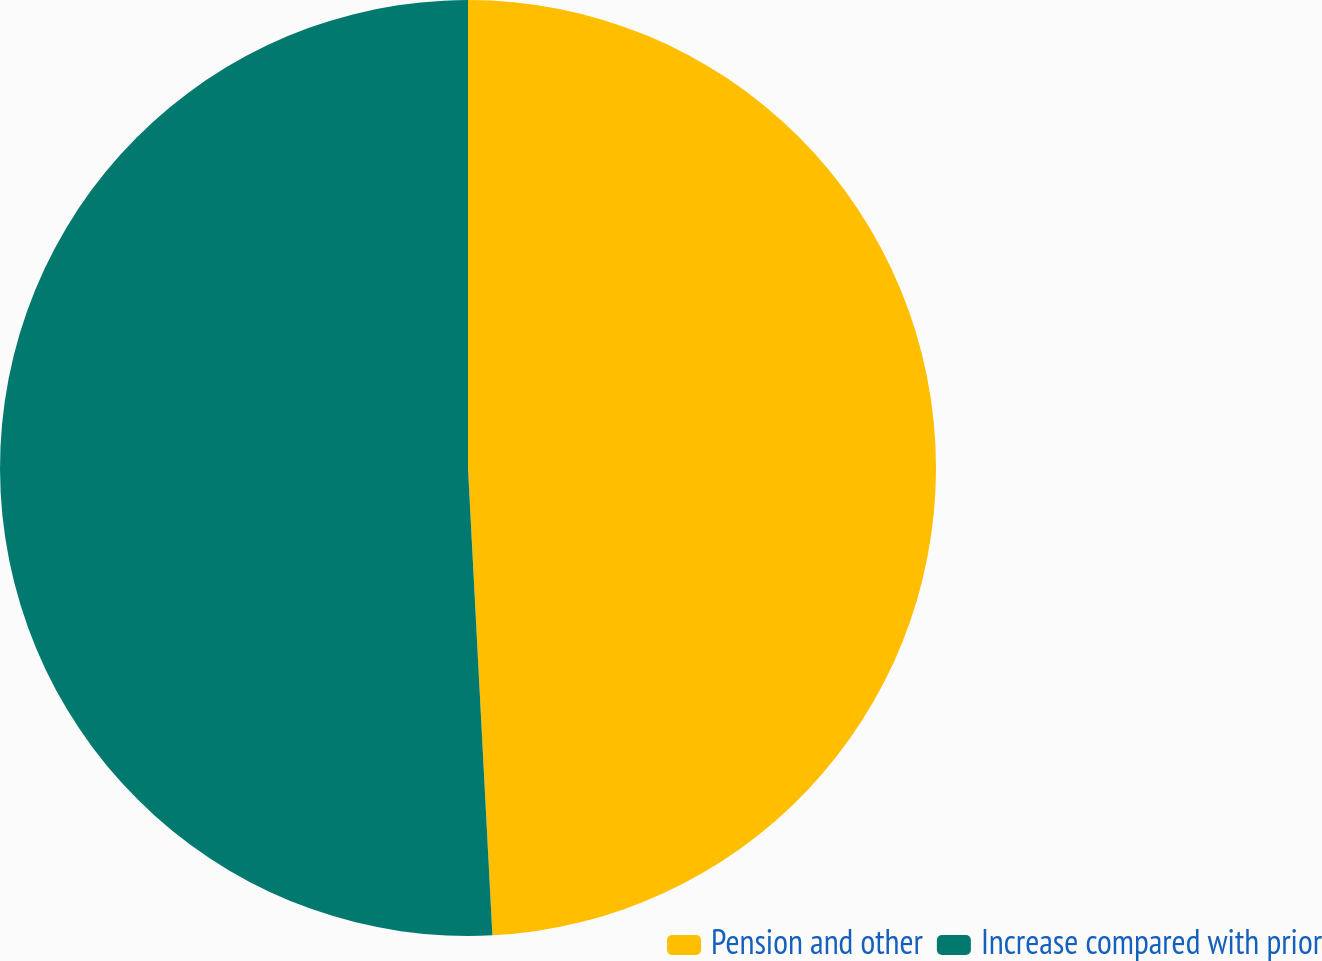Convert chart. <chart><loc_0><loc_0><loc_500><loc_500><pie_chart><fcel>Pension and other<fcel>Increase compared with prior<nl><fcel>49.17%<fcel>50.83%<nl></chart> 